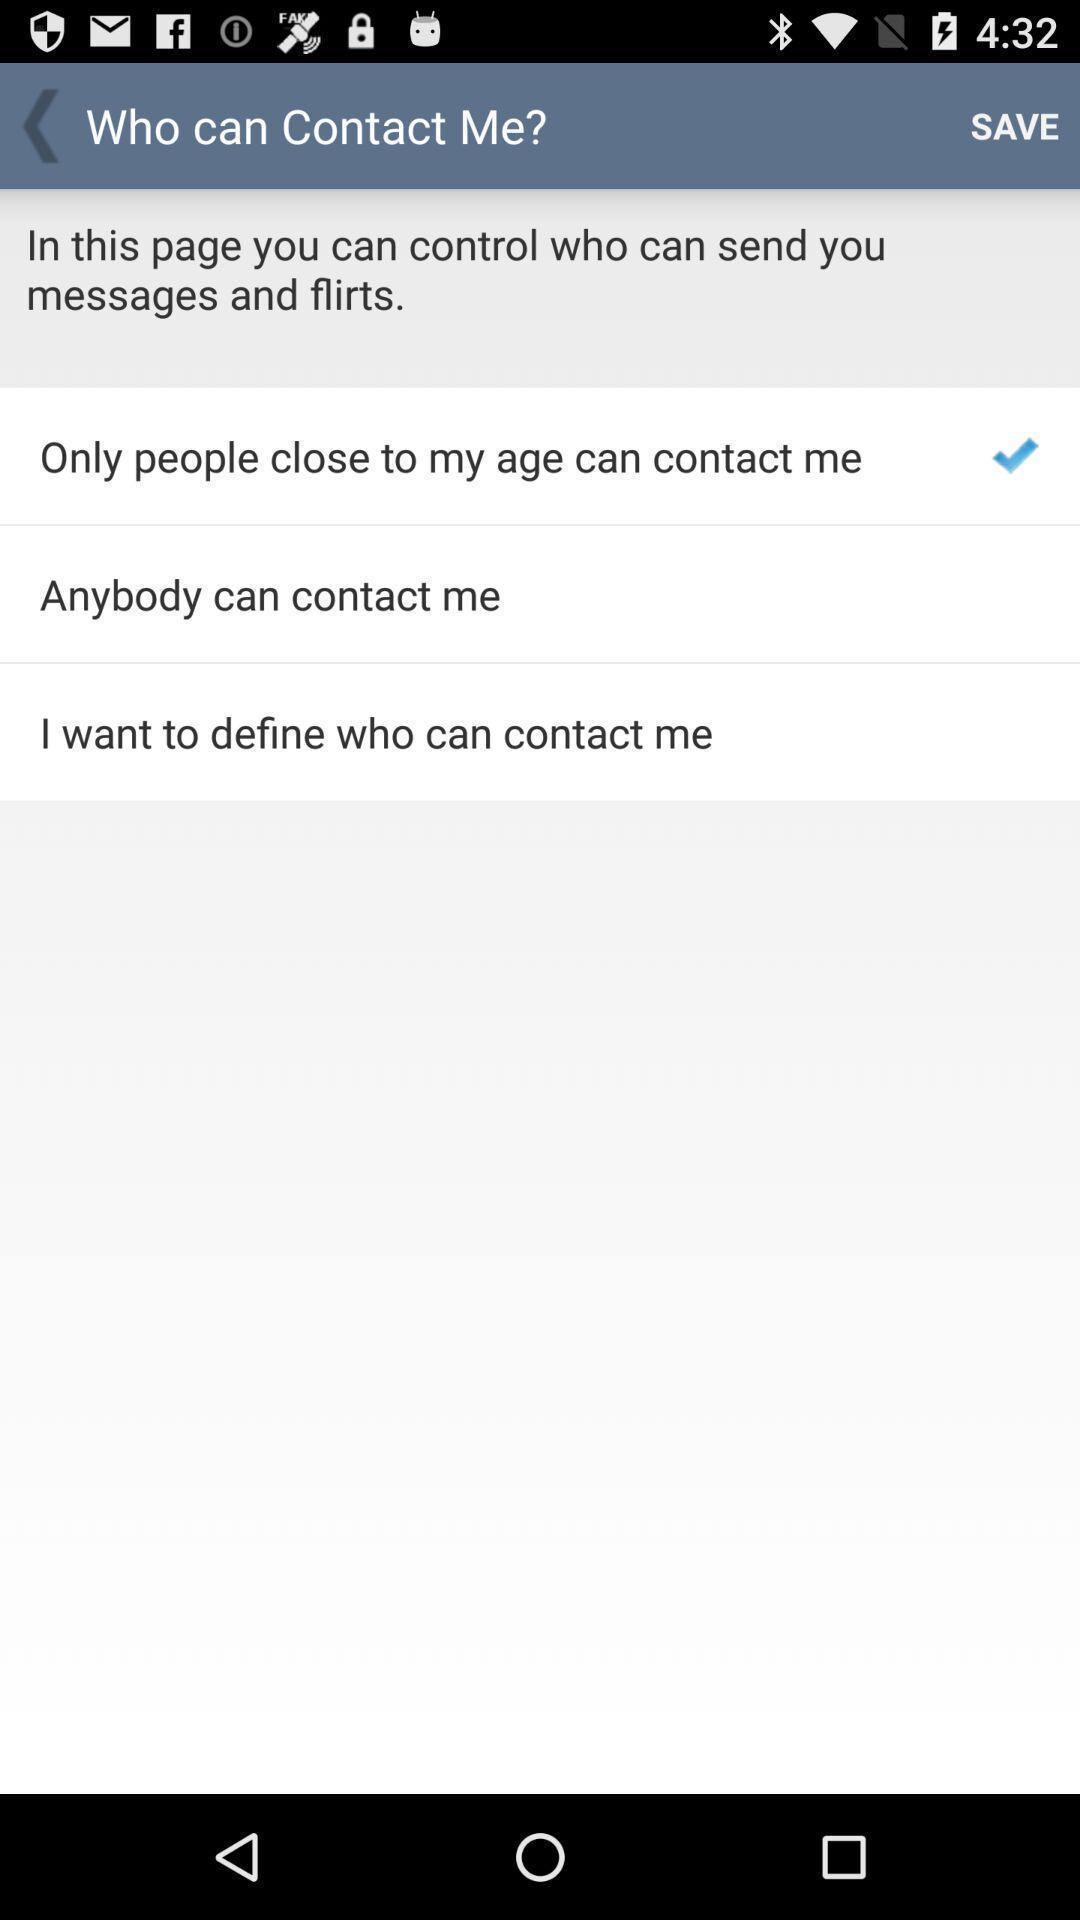Provide a detailed account of this screenshot. Settings regarding people who contact me. 